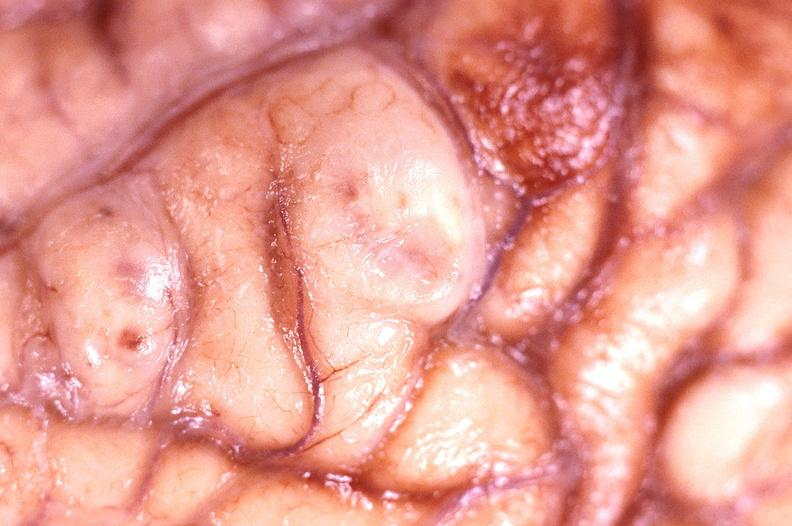what does this image show?
Answer the question using a single word or phrase. Brain abscess 